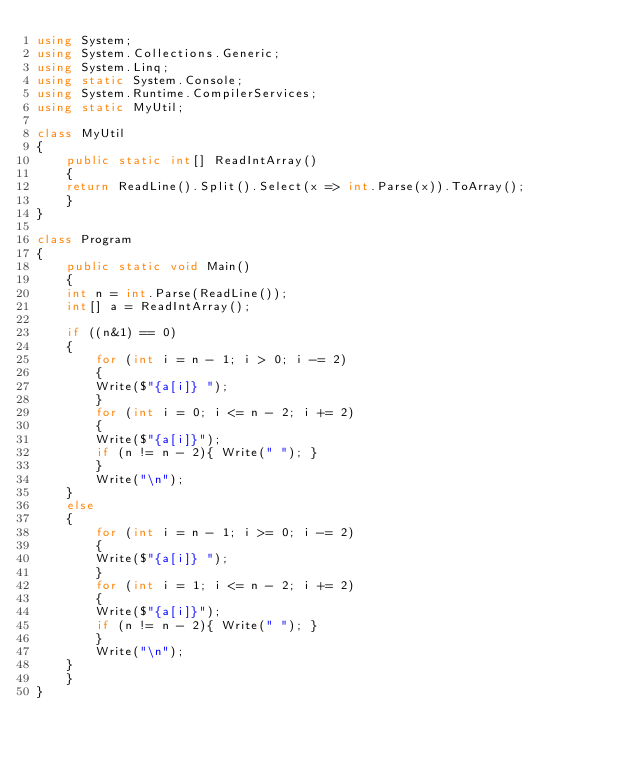Convert code to text. <code><loc_0><loc_0><loc_500><loc_500><_C#_>using System;
using System.Collections.Generic;
using System.Linq;
using static System.Console;
using System.Runtime.CompilerServices;
using static MyUtil;

class MyUtil
{
    public static int[] ReadIntArray()
    {
	return ReadLine().Split().Select(x => int.Parse(x)).ToArray();
    }
}

class Program
{
    public static void Main()
    {
	int n = int.Parse(ReadLine());
	int[] a = ReadIntArray();

	if ((n&1) == 0)
	{
	    for (int i = n - 1; i > 0; i -= 2)
	    {
		Write($"{a[i]} ");
	    }
	    for (int i = 0; i <= n - 2; i += 2)
	    {
		Write($"{a[i]}");
		if (n != n - 2){ Write(" "); }
	    }
	    Write("\n");
	}
	else
	{
	    for (int i = n - 1; i >= 0; i -= 2)
	    {
		Write($"{a[i]} ");
	    }
	    for (int i = 1; i <= n - 2; i += 2)
	    {
		Write($"{a[i]}");
		if (n != n - 2){ Write(" "); }
	    }
	    Write("\n");
	}
    }
}
</code> 